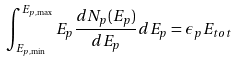<formula> <loc_0><loc_0><loc_500><loc_500>\int _ { E _ { p , \min } } ^ { E _ { p , \max } } E _ { p } \frac { d N _ { p } ( E _ { p } ) } { d E _ { p } } d E _ { p } = \epsilon _ { p } E _ { t o t }</formula> 